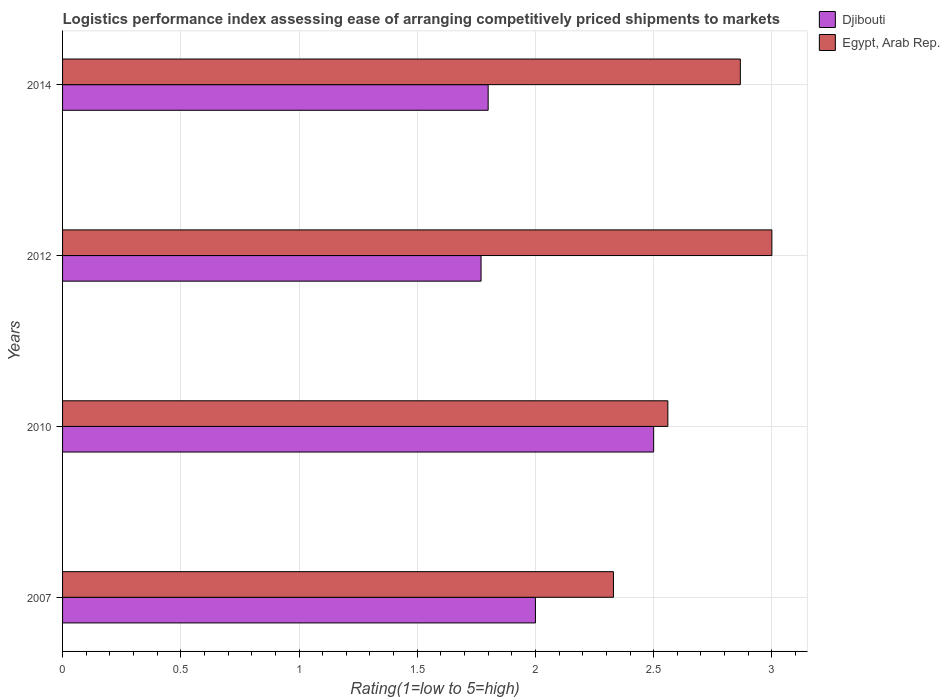Are the number of bars per tick equal to the number of legend labels?
Your answer should be compact. Yes. Are the number of bars on each tick of the Y-axis equal?
Offer a terse response. Yes. How many bars are there on the 3rd tick from the bottom?
Offer a terse response. 2. In how many cases, is the number of bars for a given year not equal to the number of legend labels?
Your answer should be very brief. 0. What is the Logistic performance index in Djibouti in 2012?
Your answer should be very brief. 1.77. Across all years, what is the maximum Logistic performance index in Egypt, Arab Rep.?
Give a very brief answer. 3. Across all years, what is the minimum Logistic performance index in Djibouti?
Your answer should be very brief. 1.77. In which year was the Logistic performance index in Djibouti maximum?
Make the answer very short. 2010. What is the total Logistic performance index in Djibouti in the graph?
Ensure brevity in your answer.  8.07. What is the difference between the Logistic performance index in Egypt, Arab Rep. in 2007 and that in 2010?
Provide a succinct answer. -0.23. What is the difference between the Logistic performance index in Egypt, Arab Rep. in 2007 and the Logistic performance index in Djibouti in 2012?
Make the answer very short. 0.56. What is the average Logistic performance index in Djibouti per year?
Your answer should be very brief. 2.02. In the year 2010, what is the difference between the Logistic performance index in Djibouti and Logistic performance index in Egypt, Arab Rep.?
Your answer should be compact. -0.06. What is the ratio of the Logistic performance index in Egypt, Arab Rep. in 2012 to that in 2014?
Offer a terse response. 1.05. Is the Logistic performance index in Djibouti in 2007 less than that in 2010?
Ensure brevity in your answer.  Yes. Is the difference between the Logistic performance index in Djibouti in 2007 and 2014 greater than the difference between the Logistic performance index in Egypt, Arab Rep. in 2007 and 2014?
Provide a short and direct response. Yes. What is the difference between the highest and the second highest Logistic performance index in Djibouti?
Give a very brief answer. 0.5. What is the difference between the highest and the lowest Logistic performance index in Egypt, Arab Rep.?
Make the answer very short. 0.67. In how many years, is the Logistic performance index in Egypt, Arab Rep. greater than the average Logistic performance index in Egypt, Arab Rep. taken over all years?
Give a very brief answer. 2. What does the 2nd bar from the top in 2014 represents?
Provide a succinct answer. Djibouti. What does the 1st bar from the bottom in 2007 represents?
Your answer should be compact. Djibouti. Are all the bars in the graph horizontal?
Your response must be concise. Yes. Are the values on the major ticks of X-axis written in scientific E-notation?
Make the answer very short. No. Does the graph contain any zero values?
Make the answer very short. No. Does the graph contain grids?
Your answer should be compact. Yes. How are the legend labels stacked?
Provide a short and direct response. Vertical. What is the title of the graph?
Provide a succinct answer. Logistics performance index assessing ease of arranging competitively priced shipments to markets. Does "Senegal" appear as one of the legend labels in the graph?
Offer a very short reply. No. What is the label or title of the X-axis?
Provide a succinct answer. Rating(1=low to 5=high). What is the Rating(1=low to 5=high) of Egypt, Arab Rep. in 2007?
Make the answer very short. 2.33. What is the Rating(1=low to 5=high) of Egypt, Arab Rep. in 2010?
Ensure brevity in your answer.  2.56. What is the Rating(1=low to 5=high) in Djibouti in 2012?
Keep it short and to the point. 1.77. What is the Rating(1=low to 5=high) of Djibouti in 2014?
Ensure brevity in your answer.  1.8. What is the Rating(1=low to 5=high) of Egypt, Arab Rep. in 2014?
Offer a very short reply. 2.87. Across all years, what is the maximum Rating(1=low to 5=high) in Djibouti?
Provide a succinct answer. 2.5. Across all years, what is the maximum Rating(1=low to 5=high) of Egypt, Arab Rep.?
Offer a terse response. 3. Across all years, what is the minimum Rating(1=low to 5=high) of Djibouti?
Keep it short and to the point. 1.77. Across all years, what is the minimum Rating(1=low to 5=high) in Egypt, Arab Rep.?
Your response must be concise. 2.33. What is the total Rating(1=low to 5=high) of Djibouti in the graph?
Ensure brevity in your answer.  8.07. What is the total Rating(1=low to 5=high) in Egypt, Arab Rep. in the graph?
Your answer should be very brief. 10.76. What is the difference between the Rating(1=low to 5=high) in Djibouti in 2007 and that in 2010?
Ensure brevity in your answer.  -0.5. What is the difference between the Rating(1=low to 5=high) of Egypt, Arab Rep. in 2007 and that in 2010?
Provide a succinct answer. -0.23. What is the difference between the Rating(1=low to 5=high) of Djibouti in 2007 and that in 2012?
Your answer should be compact. 0.23. What is the difference between the Rating(1=low to 5=high) of Egypt, Arab Rep. in 2007 and that in 2012?
Offer a terse response. -0.67. What is the difference between the Rating(1=low to 5=high) of Egypt, Arab Rep. in 2007 and that in 2014?
Give a very brief answer. -0.54. What is the difference between the Rating(1=low to 5=high) of Djibouti in 2010 and that in 2012?
Your answer should be very brief. 0.73. What is the difference between the Rating(1=low to 5=high) of Egypt, Arab Rep. in 2010 and that in 2012?
Keep it short and to the point. -0.44. What is the difference between the Rating(1=low to 5=high) of Egypt, Arab Rep. in 2010 and that in 2014?
Make the answer very short. -0.31. What is the difference between the Rating(1=low to 5=high) of Djibouti in 2012 and that in 2014?
Provide a succinct answer. -0.03. What is the difference between the Rating(1=low to 5=high) in Egypt, Arab Rep. in 2012 and that in 2014?
Provide a short and direct response. 0.13. What is the difference between the Rating(1=low to 5=high) of Djibouti in 2007 and the Rating(1=low to 5=high) of Egypt, Arab Rep. in 2010?
Make the answer very short. -0.56. What is the difference between the Rating(1=low to 5=high) of Djibouti in 2007 and the Rating(1=low to 5=high) of Egypt, Arab Rep. in 2012?
Make the answer very short. -1. What is the difference between the Rating(1=low to 5=high) in Djibouti in 2007 and the Rating(1=low to 5=high) in Egypt, Arab Rep. in 2014?
Keep it short and to the point. -0.87. What is the difference between the Rating(1=low to 5=high) in Djibouti in 2010 and the Rating(1=low to 5=high) in Egypt, Arab Rep. in 2014?
Offer a terse response. -0.37. What is the difference between the Rating(1=low to 5=high) of Djibouti in 2012 and the Rating(1=low to 5=high) of Egypt, Arab Rep. in 2014?
Offer a very short reply. -1.1. What is the average Rating(1=low to 5=high) in Djibouti per year?
Provide a succinct answer. 2.02. What is the average Rating(1=low to 5=high) in Egypt, Arab Rep. per year?
Make the answer very short. 2.69. In the year 2007, what is the difference between the Rating(1=low to 5=high) in Djibouti and Rating(1=low to 5=high) in Egypt, Arab Rep.?
Offer a terse response. -0.33. In the year 2010, what is the difference between the Rating(1=low to 5=high) of Djibouti and Rating(1=low to 5=high) of Egypt, Arab Rep.?
Give a very brief answer. -0.06. In the year 2012, what is the difference between the Rating(1=low to 5=high) of Djibouti and Rating(1=low to 5=high) of Egypt, Arab Rep.?
Provide a succinct answer. -1.23. In the year 2014, what is the difference between the Rating(1=low to 5=high) of Djibouti and Rating(1=low to 5=high) of Egypt, Arab Rep.?
Your answer should be compact. -1.07. What is the ratio of the Rating(1=low to 5=high) in Djibouti in 2007 to that in 2010?
Give a very brief answer. 0.8. What is the ratio of the Rating(1=low to 5=high) in Egypt, Arab Rep. in 2007 to that in 2010?
Your answer should be very brief. 0.91. What is the ratio of the Rating(1=low to 5=high) of Djibouti in 2007 to that in 2012?
Your answer should be compact. 1.13. What is the ratio of the Rating(1=low to 5=high) in Egypt, Arab Rep. in 2007 to that in 2012?
Your answer should be compact. 0.78. What is the ratio of the Rating(1=low to 5=high) in Djibouti in 2007 to that in 2014?
Keep it short and to the point. 1.11. What is the ratio of the Rating(1=low to 5=high) in Egypt, Arab Rep. in 2007 to that in 2014?
Your answer should be compact. 0.81. What is the ratio of the Rating(1=low to 5=high) of Djibouti in 2010 to that in 2012?
Offer a terse response. 1.41. What is the ratio of the Rating(1=low to 5=high) in Egypt, Arab Rep. in 2010 to that in 2012?
Keep it short and to the point. 0.85. What is the ratio of the Rating(1=low to 5=high) in Djibouti in 2010 to that in 2014?
Make the answer very short. 1.39. What is the ratio of the Rating(1=low to 5=high) in Egypt, Arab Rep. in 2010 to that in 2014?
Your answer should be very brief. 0.89. What is the ratio of the Rating(1=low to 5=high) of Djibouti in 2012 to that in 2014?
Provide a succinct answer. 0.98. What is the ratio of the Rating(1=low to 5=high) in Egypt, Arab Rep. in 2012 to that in 2014?
Your response must be concise. 1.05. What is the difference between the highest and the second highest Rating(1=low to 5=high) of Egypt, Arab Rep.?
Provide a succinct answer. 0.13. What is the difference between the highest and the lowest Rating(1=low to 5=high) in Djibouti?
Your answer should be compact. 0.73. What is the difference between the highest and the lowest Rating(1=low to 5=high) in Egypt, Arab Rep.?
Offer a very short reply. 0.67. 